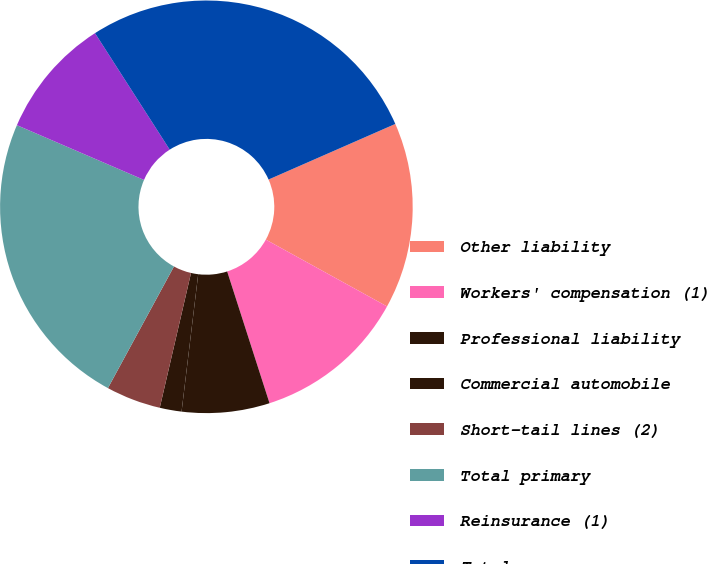Convert chart to OTSL. <chart><loc_0><loc_0><loc_500><loc_500><pie_chart><fcel>Other liability<fcel>Workers' compensation (1)<fcel>Professional liability<fcel>Commercial automobile<fcel>Short-tail lines (2)<fcel>Total primary<fcel>Reinsurance (1)<fcel>Total<nl><fcel>14.6%<fcel>12.03%<fcel>6.87%<fcel>1.71%<fcel>4.29%<fcel>23.56%<fcel>9.45%<fcel>27.5%<nl></chart> 